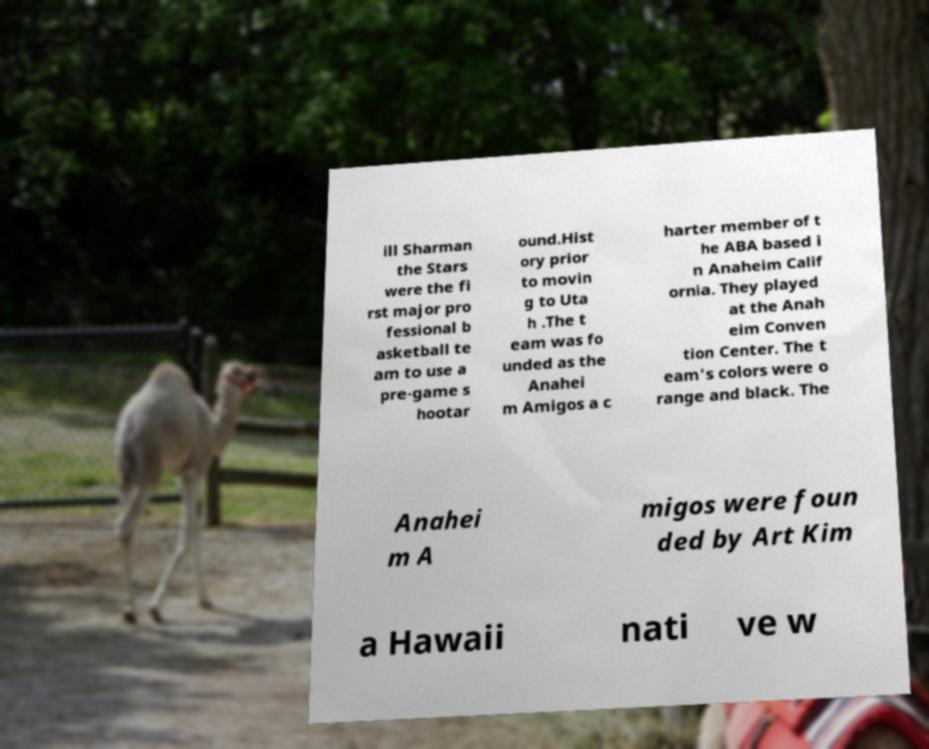Could you extract and type out the text from this image? ill Sharman the Stars were the fi rst major pro fessional b asketball te am to use a pre-game s hootar ound.Hist ory prior to movin g to Uta h .The t eam was fo unded as the Anahei m Amigos a c harter member of t he ABA based i n Anaheim Calif ornia. They played at the Anah eim Conven tion Center. The t eam's colors were o range and black. The Anahei m A migos were foun ded by Art Kim a Hawaii nati ve w 